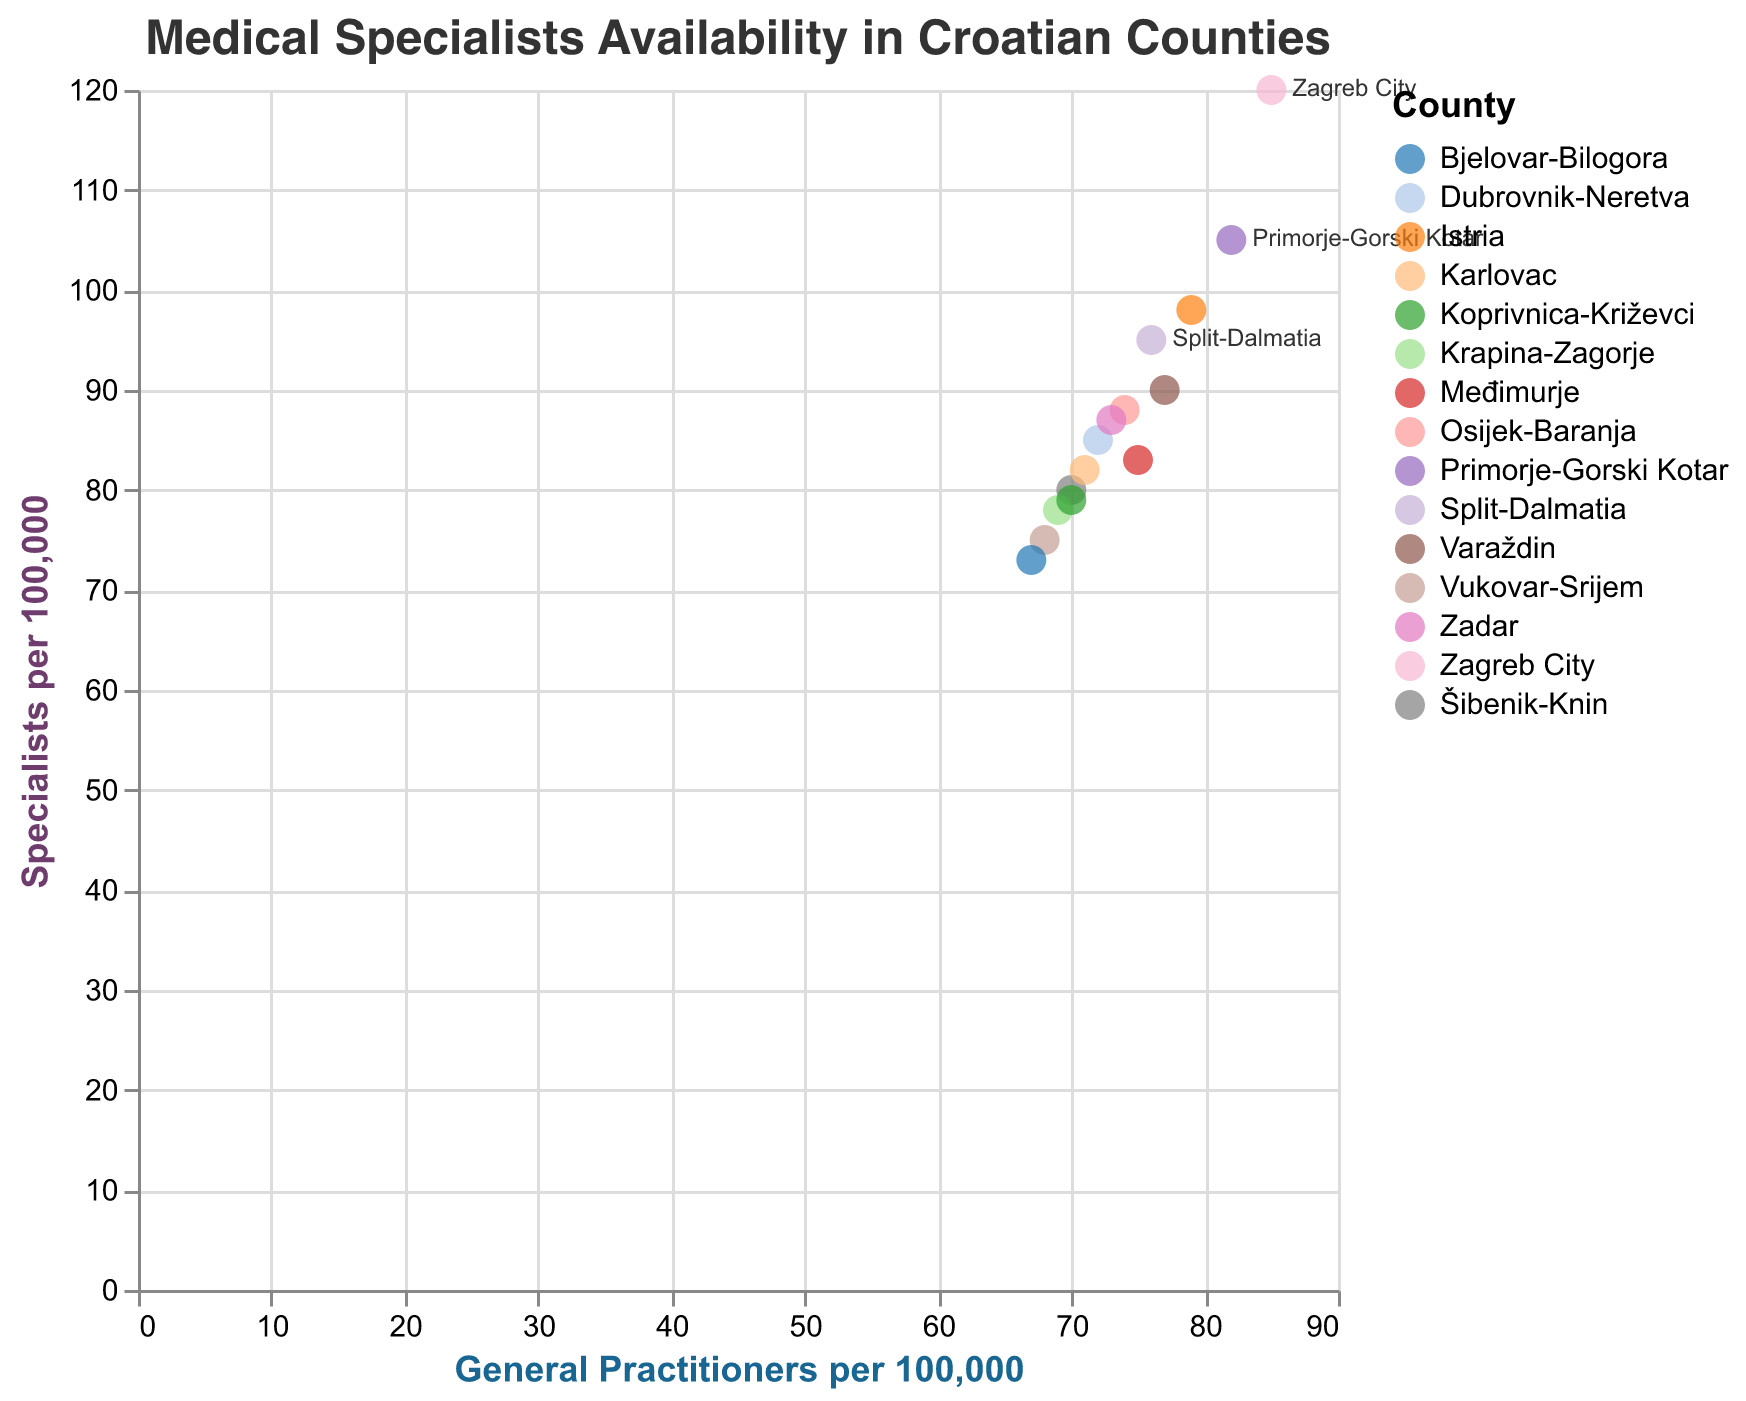what is the title of the figure? The title is often prominently displayed at the top of the figure. In this case, it reads "Medical Specialists Availability in Croatian Counties".
Answer: Medical Specialists Availability in Croatian Counties How many counties have more than 80 general practitioners per 100,000? We need to count the points that have a value greater than 80 on the x-axis. The counties are Zagreb City, Split-Dalmatia, and Primorje-Gorski Kotar.
Answer: 3 Which county has the highest number of specialists per 100,000? Looking at the y-axis values, the highest point corresponds to Zagreb City with 120 specialists per 100,000.
Answer: Zagreb City For which counties is availability of general practitioners equal to the availability of specialists? We look for points on a diagonal line where x (General Practitioners) equals y (Specialists). In this case, there are no such points.
Answer: None What is the difference in the number of specialists per 100,000 between Dubrovnik-Neretva and Zagreb City? Dubrovnik-Neretva has 85 specialists per 100,000 and Zagreb City has 120. The difference is 120 - 85.
Answer: 35 Which counties have a higher number of general practitioners relative to specialists? We need points above the diagonal that runs from the bottom left to top right. Counties are Zagreb City, Split-Dalmatia, Primorje-Gorski Kotar, Osijek-Baranja, Istria, Dubrovnik-Neretva, Varaždin, and Koprivnica-Križevci.
Answer: 8 How does the number of general practitioners per 100,000 in Bjelovar-Bilogora compare with that in Varaždin? Bjelovar-Bilogora has 67 general practitioners per 100,000, while Varaždin has 77. 77 - 67 = 10 more in Varaždin.
Answer: 10 more in Varaždin What is the range of specialists per 100,000 among the counties? The range is found by subtracting the smallest value from the largest. The highest is 120 in Zagreb City and the lowest is 73 in Bjelovar-Bilogora, so 120 - 73.
Answer: 47 Which counties have less than 70 general practitioners per 100,000? Looking at the x-axis for points that fall below 70, the counties are Vukovar-Srijem and Bjelovar-Bilogora.
Answer: 2 Is there a trend between the number of general practitioners and specialists in the counties? By observing the general distribution of points: as the number of general practitioners increases, the number of specialists also generally increases.
Answer: Yes 